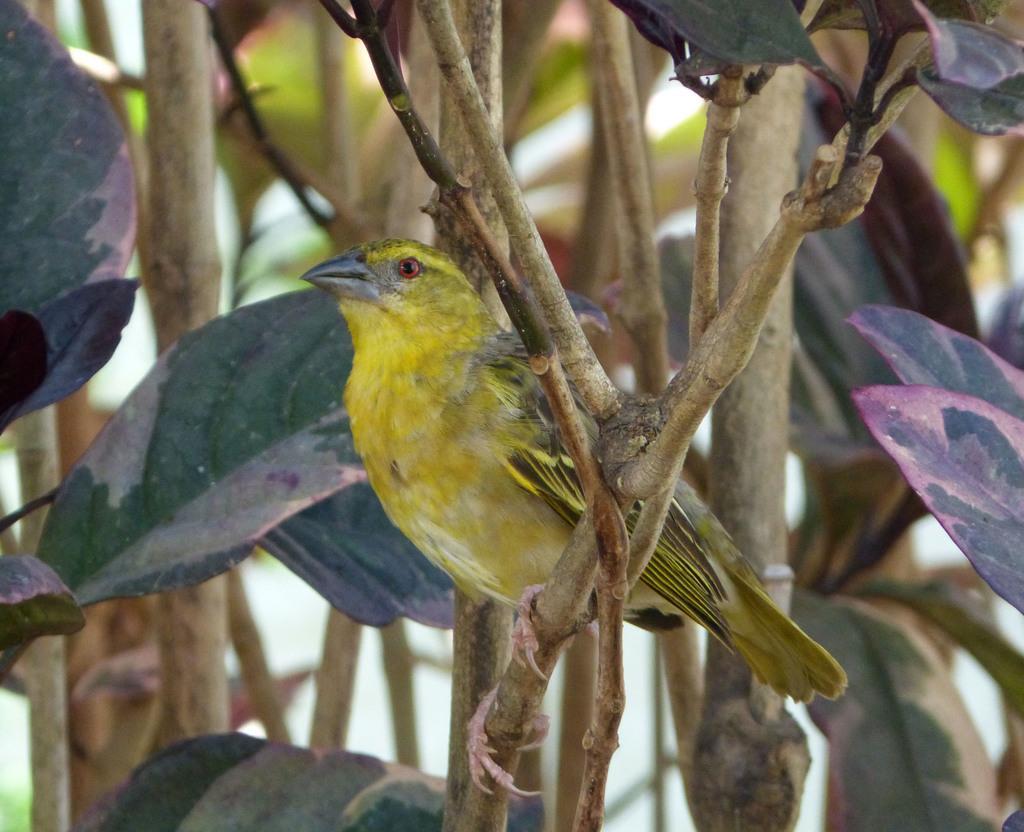Can you describe this image briefly? In this image we can see a yellow color bird is sitting on the stem of a tree. Behind so many leaves are there. 